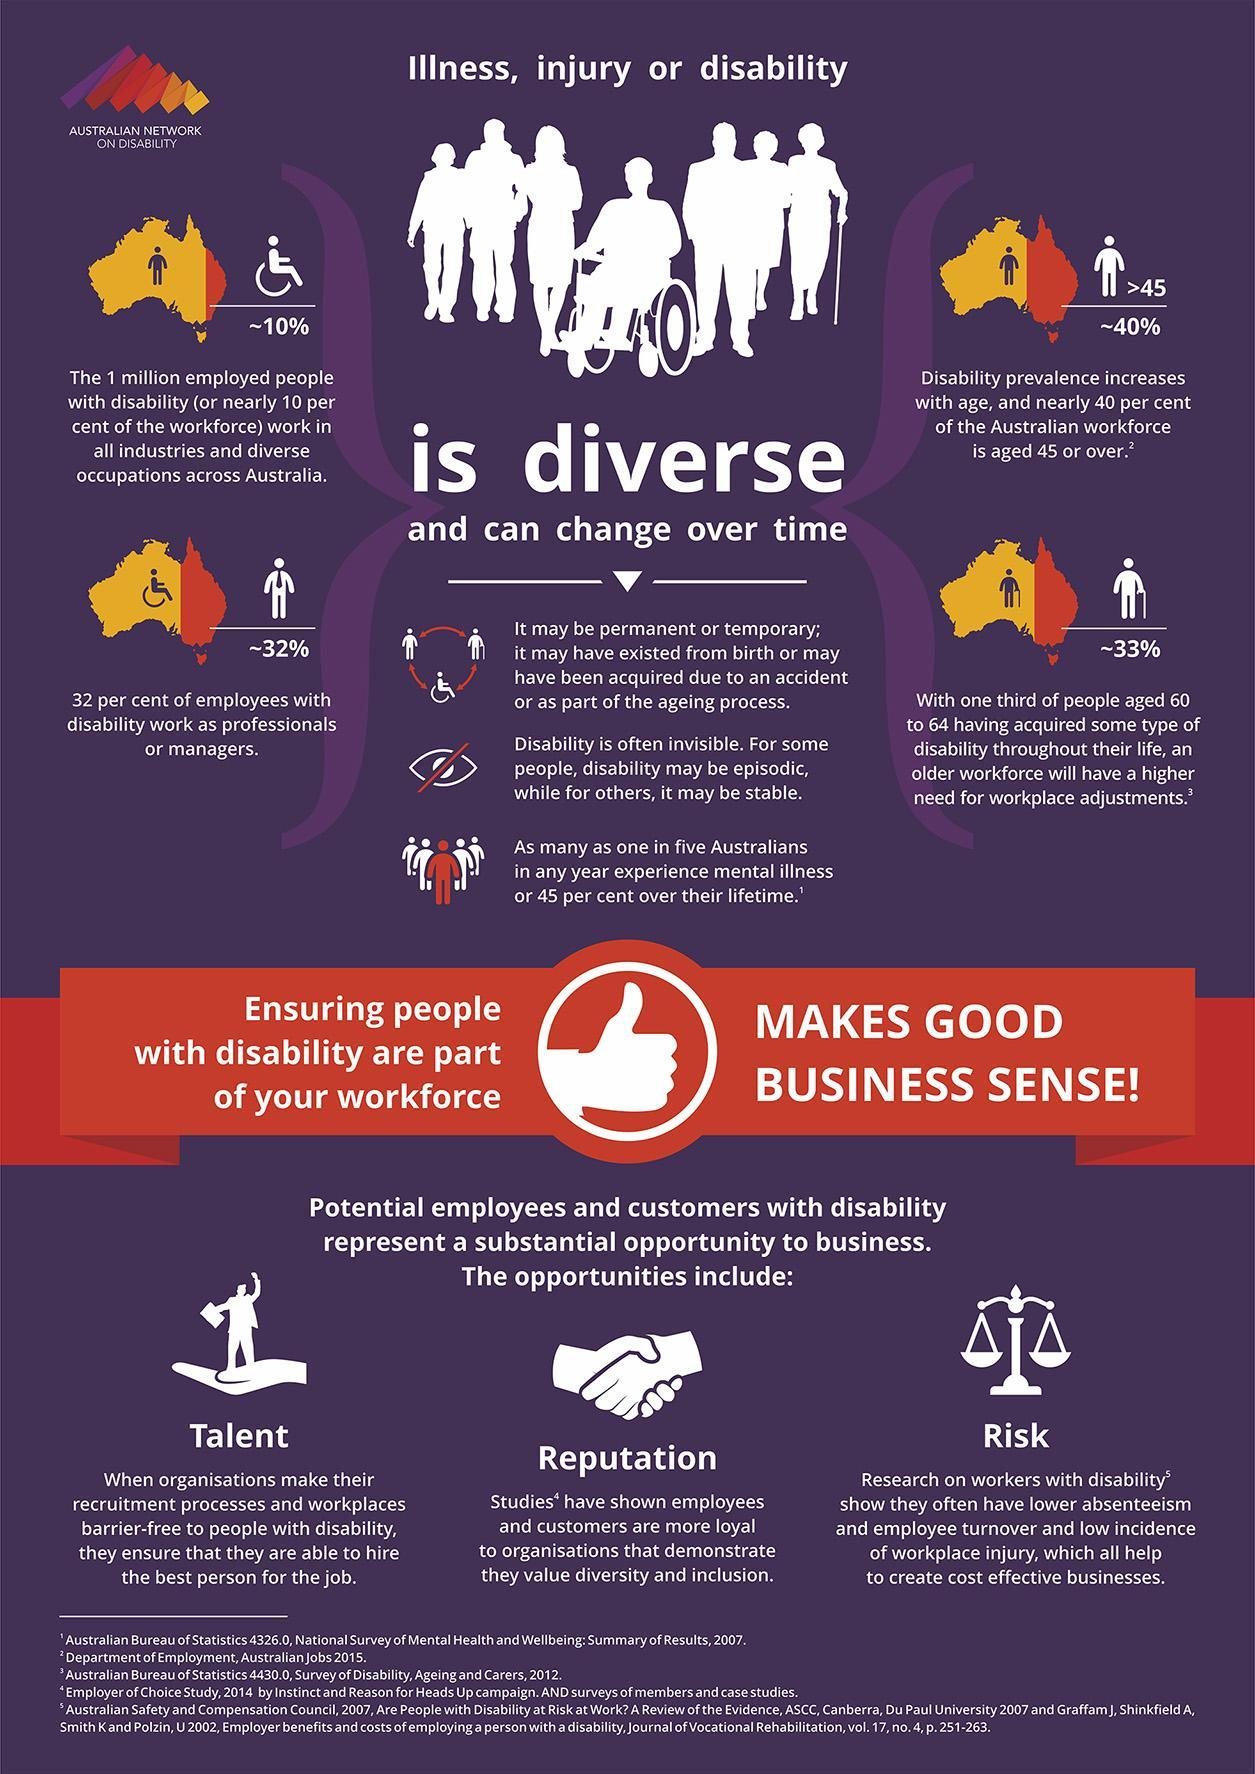What things are considered as diverse & can change over time?
Answer the question with a short phrase. Illness, injury or disability What percent of employees with disability do not work as professionals or managers? 68% 